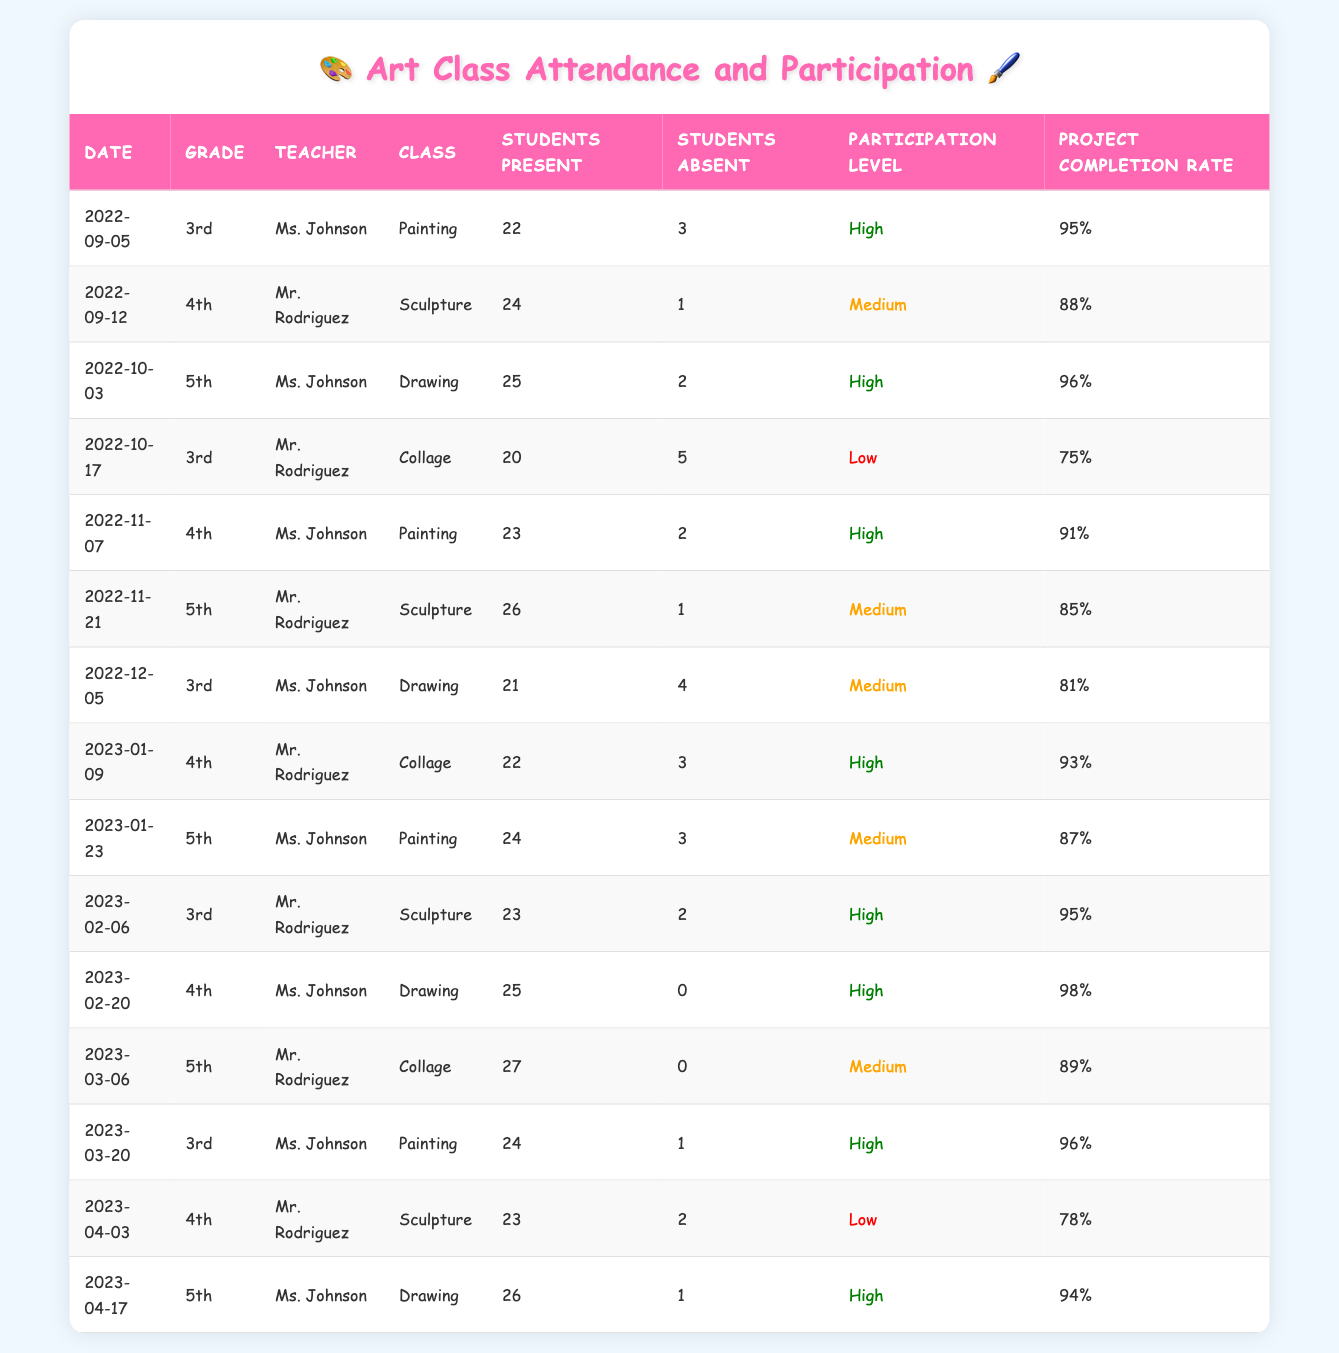What is the highest project completion rate in the table? To find the highest project completion rate, we look through the "Project Completion Rate" column. The highest rate noted is 98%, which occurs in the 4th grade class on 2023-02-20.
Answer: 98% How many students were absent in Ms. Johnson's painting class on 2023-01-23? In the row corresponding to 2023-01-23 under Ms. Johnson's painting class, the "Students Absent" column shows a value of 3.
Answer: 3 What is the average number of students present in Mr. Rodriguez's sculpture classes? Mr. Rodriguez conducted sculpture classes on 2022-09-12 with 24 students present, and on 2023-02-06 with 23 present, and on 2023-04-03 with 23 present. The average is (24 + 23 + 23) / 3 = 70 / 3 = approximately 23.33.
Answer: 23.33 Did any 5th grade class have a low participation level? We examine the table for 5th grade classes and find that there is no entry under the "Participation Level" column marked as "Low"; therefore, the answer is false.
Answer: No What grade had the highest number of students present on 2023-03-06? We compare the number of students present across all grades for 2023-03-06: 27 in 5th grade, 24 in 3rd grade, and 23 in 4th grade. The highest is 27 students in the 5th grade class.
Answer: 5th What was the participation level during the 3rd grade painting class on 2023-03-20? Checking the row for 2023-03-20, we see that the "Participation Level" for the 3rd grade painting class is marked as "High".
Answer: High What is the total number of students absent across all classes on 2022-11-21? Checking the row for 2022-11-21, we see in the "Students Absent" column that there was 1 student absent in Mr. Rodriguez's sculpture class. Therefore, the total on this date is 1.
Answer: 1 Which teacher had the most high participation levels recorded in the table? Analyzing the participation levels from each row, Ms. Johnson had high participation levels on multiple occasions: 2022-09-05 (High), 2022-11-07 (High), 2023-02-20 (High), and 2023-03-20 (High). This totals to 4 instances, which is more than any other teacher.
Answer: Ms. Johnson What was the project completion rate for the 4th grade class on 2023-01-09? Looking at the 4th grade class on this date, the "Project Completion Rate" column indicates a rate of 93%.
Answer: 93% 